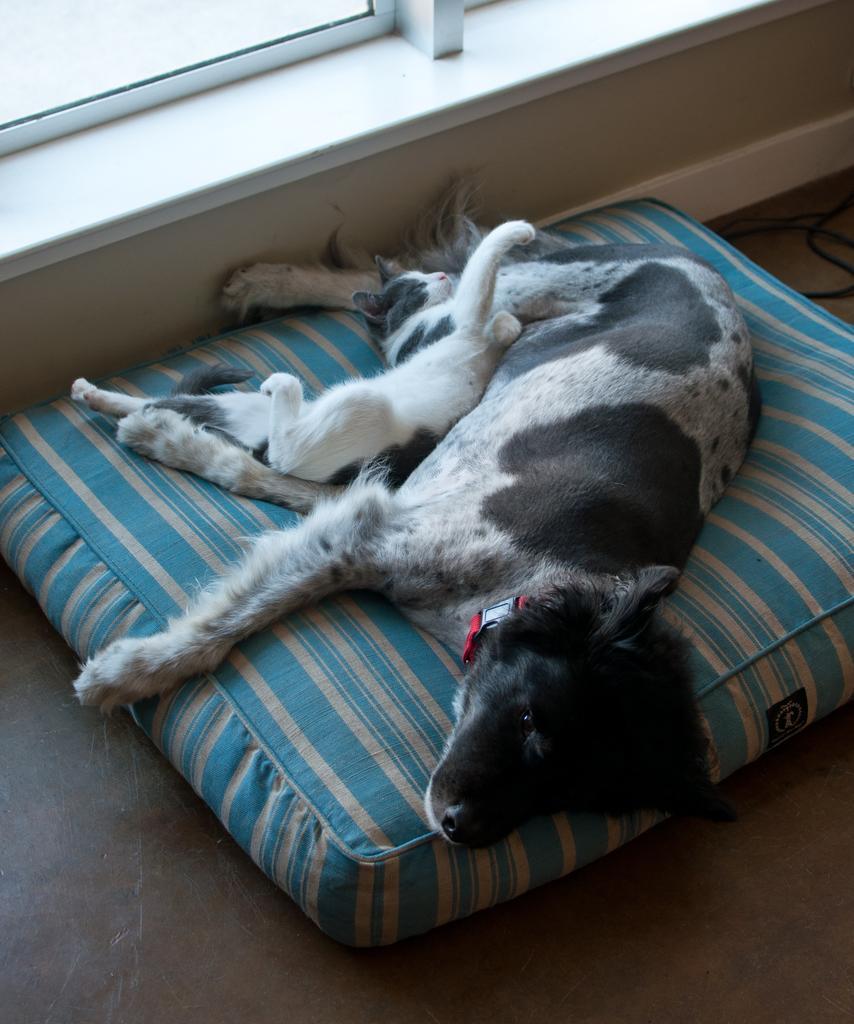Can you describe this image briefly? In this image in the center there are animals sleeping on the bed. On the top there is a window which is white in colour and not the right side there is a wire which is black in colour. 